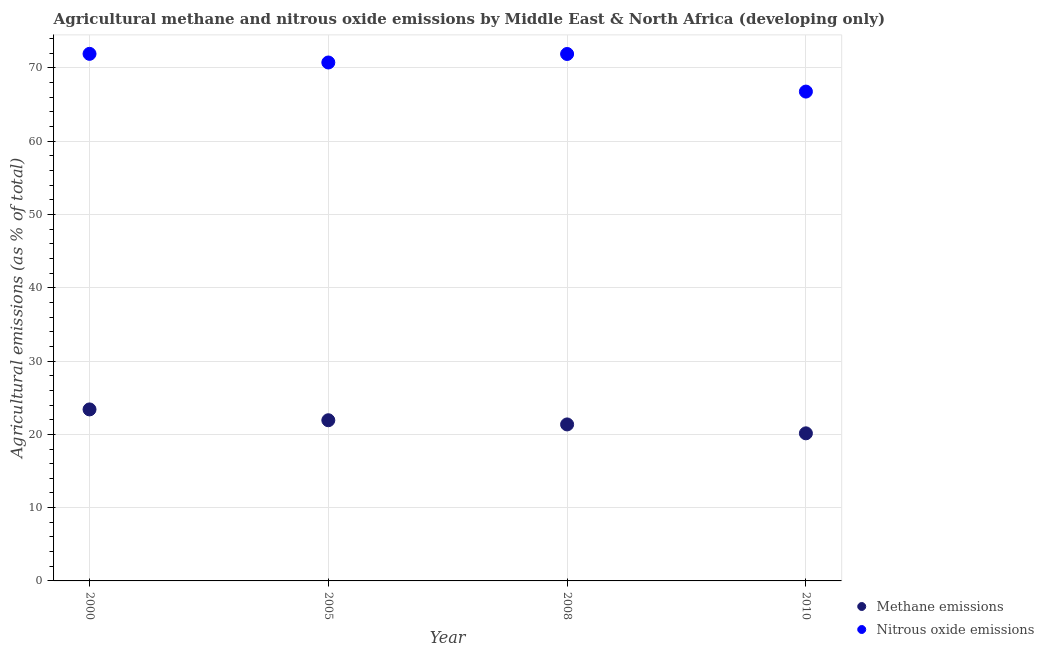How many different coloured dotlines are there?
Your answer should be very brief. 2. Is the number of dotlines equal to the number of legend labels?
Your answer should be compact. Yes. What is the amount of methane emissions in 2005?
Make the answer very short. 21.93. Across all years, what is the maximum amount of methane emissions?
Give a very brief answer. 23.4. Across all years, what is the minimum amount of nitrous oxide emissions?
Provide a short and direct response. 66.77. In which year was the amount of nitrous oxide emissions maximum?
Offer a terse response. 2000. What is the total amount of nitrous oxide emissions in the graph?
Keep it short and to the point. 281.34. What is the difference between the amount of methane emissions in 2005 and that in 2010?
Offer a terse response. 1.79. What is the difference between the amount of methane emissions in 2010 and the amount of nitrous oxide emissions in 2000?
Provide a short and direct response. -51.78. What is the average amount of methane emissions per year?
Make the answer very short. 21.71. In the year 2008, what is the difference between the amount of methane emissions and amount of nitrous oxide emissions?
Ensure brevity in your answer.  -50.55. What is the ratio of the amount of nitrous oxide emissions in 2005 to that in 2010?
Keep it short and to the point. 1.06. Is the difference between the amount of methane emissions in 2005 and 2008 greater than the difference between the amount of nitrous oxide emissions in 2005 and 2008?
Ensure brevity in your answer.  Yes. What is the difference between the highest and the second highest amount of methane emissions?
Give a very brief answer. 1.48. What is the difference between the highest and the lowest amount of nitrous oxide emissions?
Offer a terse response. 5.15. Does the amount of nitrous oxide emissions monotonically increase over the years?
Make the answer very short. No. What is the difference between two consecutive major ticks on the Y-axis?
Offer a very short reply. 10. Are the values on the major ticks of Y-axis written in scientific E-notation?
Ensure brevity in your answer.  No. Does the graph contain any zero values?
Provide a short and direct response. No. How many legend labels are there?
Keep it short and to the point. 2. What is the title of the graph?
Provide a short and direct response. Agricultural methane and nitrous oxide emissions by Middle East & North Africa (developing only). What is the label or title of the X-axis?
Keep it short and to the point. Year. What is the label or title of the Y-axis?
Ensure brevity in your answer.  Agricultural emissions (as % of total). What is the Agricultural emissions (as % of total) of Methane emissions in 2000?
Offer a terse response. 23.4. What is the Agricultural emissions (as % of total) in Nitrous oxide emissions in 2000?
Your answer should be very brief. 71.92. What is the Agricultural emissions (as % of total) of Methane emissions in 2005?
Your response must be concise. 21.93. What is the Agricultural emissions (as % of total) of Nitrous oxide emissions in 2005?
Offer a terse response. 70.74. What is the Agricultural emissions (as % of total) of Methane emissions in 2008?
Your answer should be very brief. 21.36. What is the Agricultural emissions (as % of total) of Nitrous oxide emissions in 2008?
Keep it short and to the point. 71.9. What is the Agricultural emissions (as % of total) in Methane emissions in 2010?
Provide a short and direct response. 20.14. What is the Agricultural emissions (as % of total) of Nitrous oxide emissions in 2010?
Your response must be concise. 66.77. Across all years, what is the maximum Agricultural emissions (as % of total) of Methane emissions?
Your answer should be compact. 23.4. Across all years, what is the maximum Agricultural emissions (as % of total) in Nitrous oxide emissions?
Give a very brief answer. 71.92. Across all years, what is the minimum Agricultural emissions (as % of total) in Methane emissions?
Make the answer very short. 20.14. Across all years, what is the minimum Agricultural emissions (as % of total) of Nitrous oxide emissions?
Your answer should be compact. 66.77. What is the total Agricultural emissions (as % of total) in Methane emissions in the graph?
Provide a short and direct response. 86.83. What is the total Agricultural emissions (as % of total) in Nitrous oxide emissions in the graph?
Provide a succinct answer. 281.34. What is the difference between the Agricultural emissions (as % of total) of Methane emissions in 2000 and that in 2005?
Your answer should be compact. 1.48. What is the difference between the Agricultural emissions (as % of total) in Nitrous oxide emissions in 2000 and that in 2005?
Make the answer very short. 1.18. What is the difference between the Agricultural emissions (as % of total) in Methane emissions in 2000 and that in 2008?
Ensure brevity in your answer.  2.05. What is the difference between the Agricultural emissions (as % of total) in Nitrous oxide emissions in 2000 and that in 2008?
Give a very brief answer. 0.02. What is the difference between the Agricultural emissions (as % of total) of Methane emissions in 2000 and that in 2010?
Ensure brevity in your answer.  3.26. What is the difference between the Agricultural emissions (as % of total) of Nitrous oxide emissions in 2000 and that in 2010?
Ensure brevity in your answer.  5.15. What is the difference between the Agricultural emissions (as % of total) of Methane emissions in 2005 and that in 2008?
Ensure brevity in your answer.  0.57. What is the difference between the Agricultural emissions (as % of total) of Nitrous oxide emissions in 2005 and that in 2008?
Your answer should be very brief. -1.16. What is the difference between the Agricultural emissions (as % of total) of Methane emissions in 2005 and that in 2010?
Your answer should be very brief. 1.79. What is the difference between the Agricultural emissions (as % of total) of Nitrous oxide emissions in 2005 and that in 2010?
Your answer should be compact. 3.97. What is the difference between the Agricultural emissions (as % of total) in Methane emissions in 2008 and that in 2010?
Provide a short and direct response. 1.22. What is the difference between the Agricultural emissions (as % of total) of Nitrous oxide emissions in 2008 and that in 2010?
Make the answer very short. 5.13. What is the difference between the Agricultural emissions (as % of total) of Methane emissions in 2000 and the Agricultural emissions (as % of total) of Nitrous oxide emissions in 2005?
Make the answer very short. -47.34. What is the difference between the Agricultural emissions (as % of total) in Methane emissions in 2000 and the Agricultural emissions (as % of total) in Nitrous oxide emissions in 2008?
Provide a succinct answer. -48.5. What is the difference between the Agricultural emissions (as % of total) of Methane emissions in 2000 and the Agricultural emissions (as % of total) of Nitrous oxide emissions in 2010?
Provide a short and direct response. -43.37. What is the difference between the Agricultural emissions (as % of total) in Methane emissions in 2005 and the Agricultural emissions (as % of total) in Nitrous oxide emissions in 2008?
Provide a short and direct response. -49.98. What is the difference between the Agricultural emissions (as % of total) of Methane emissions in 2005 and the Agricultural emissions (as % of total) of Nitrous oxide emissions in 2010?
Provide a short and direct response. -44.85. What is the difference between the Agricultural emissions (as % of total) in Methane emissions in 2008 and the Agricultural emissions (as % of total) in Nitrous oxide emissions in 2010?
Provide a short and direct response. -45.42. What is the average Agricultural emissions (as % of total) in Methane emissions per year?
Your response must be concise. 21.71. What is the average Agricultural emissions (as % of total) of Nitrous oxide emissions per year?
Give a very brief answer. 70.34. In the year 2000, what is the difference between the Agricultural emissions (as % of total) in Methane emissions and Agricultural emissions (as % of total) in Nitrous oxide emissions?
Provide a succinct answer. -48.52. In the year 2005, what is the difference between the Agricultural emissions (as % of total) of Methane emissions and Agricultural emissions (as % of total) of Nitrous oxide emissions?
Ensure brevity in your answer.  -48.82. In the year 2008, what is the difference between the Agricultural emissions (as % of total) of Methane emissions and Agricultural emissions (as % of total) of Nitrous oxide emissions?
Give a very brief answer. -50.55. In the year 2010, what is the difference between the Agricultural emissions (as % of total) of Methane emissions and Agricultural emissions (as % of total) of Nitrous oxide emissions?
Make the answer very short. -46.63. What is the ratio of the Agricultural emissions (as % of total) of Methane emissions in 2000 to that in 2005?
Offer a very short reply. 1.07. What is the ratio of the Agricultural emissions (as % of total) in Nitrous oxide emissions in 2000 to that in 2005?
Offer a terse response. 1.02. What is the ratio of the Agricultural emissions (as % of total) in Methane emissions in 2000 to that in 2008?
Your response must be concise. 1.1. What is the ratio of the Agricultural emissions (as % of total) of Methane emissions in 2000 to that in 2010?
Offer a very short reply. 1.16. What is the ratio of the Agricultural emissions (as % of total) of Nitrous oxide emissions in 2000 to that in 2010?
Offer a very short reply. 1.08. What is the ratio of the Agricultural emissions (as % of total) in Methane emissions in 2005 to that in 2008?
Your answer should be very brief. 1.03. What is the ratio of the Agricultural emissions (as % of total) in Nitrous oxide emissions in 2005 to that in 2008?
Ensure brevity in your answer.  0.98. What is the ratio of the Agricultural emissions (as % of total) of Methane emissions in 2005 to that in 2010?
Ensure brevity in your answer.  1.09. What is the ratio of the Agricultural emissions (as % of total) in Nitrous oxide emissions in 2005 to that in 2010?
Offer a very short reply. 1.06. What is the ratio of the Agricultural emissions (as % of total) of Methane emissions in 2008 to that in 2010?
Offer a very short reply. 1.06. What is the ratio of the Agricultural emissions (as % of total) of Nitrous oxide emissions in 2008 to that in 2010?
Offer a very short reply. 1.08. What is the difference between the highest and the second highest Agricultural emissions (as % of total) in Methane emissions?
Make the answer very short. 1.48. What is the difference between the highest and the second highest Agricultural emissions (as % of total) in Nitrous oxide emissions?
Give a very brief answer. 0.02. What is the difference between the highest and the lowest Agricultural emissions (as % of total) in Methane emissions?
Keep it short and to the point. 3.26. What is the difference between the highest and the lowest Agricultural emissions (as % of total) of Nitrous oxide emissions?
Your answer should be compact. 5.15. 